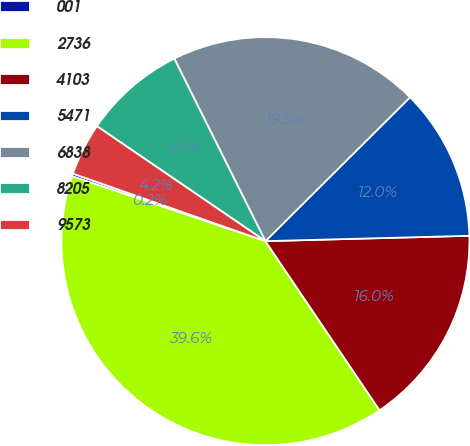<chart> <loc_0><loc_0><loc_500><loc_500><pie_chart><fcel>001<fcel>2736<fcel>4103<fcel>5471<fcel>6838<fcel>8205<fcel>9573<nl><fcel>0.22%<fcel>39.6%<fcel>15.97%<fcel>12.04%<fcel>19.91%<fcel>8.1%<fcel>4.16%<nl></chart> 